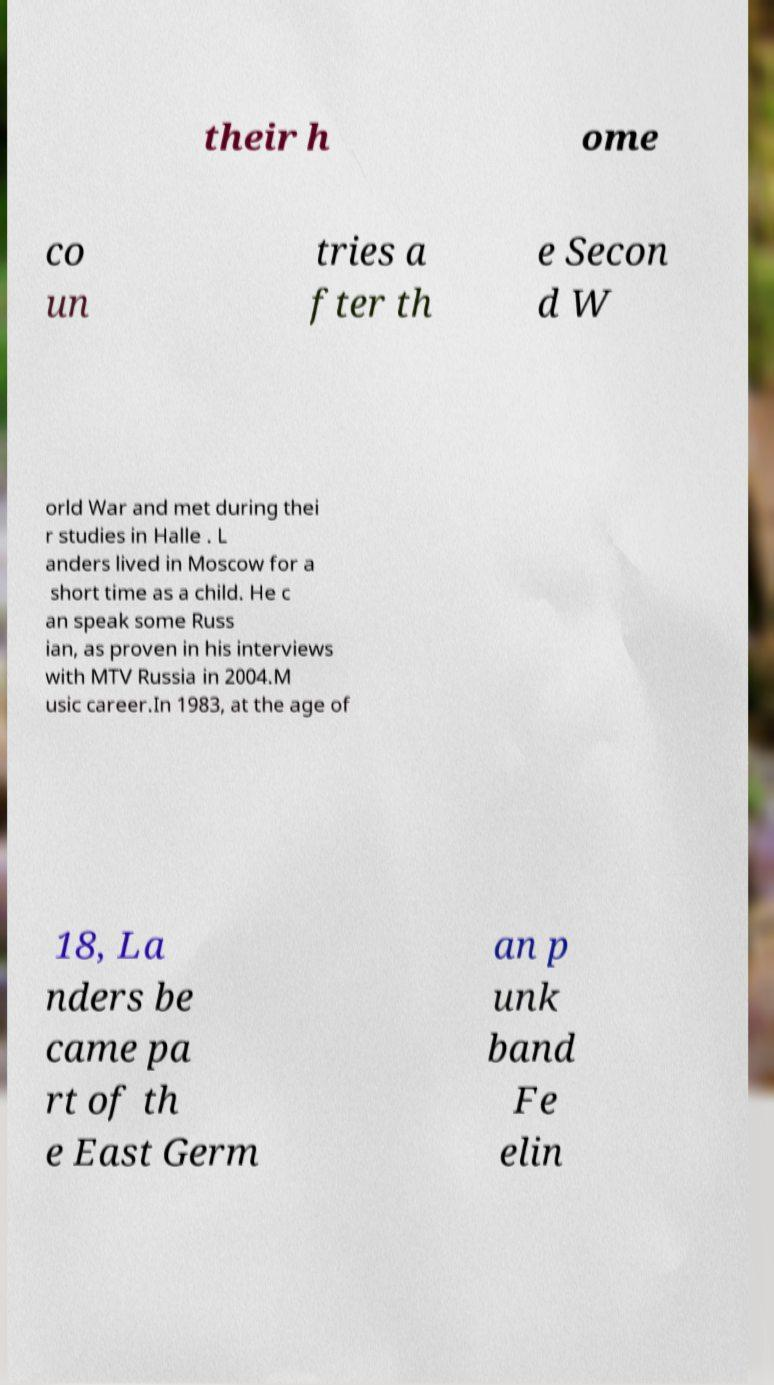Please identify and transcribe the text found in this image. their h ome co un tries a fter th e Secon d W orld War and met during thei r studies in Halle . L anders lived in Moscow for a short time as a child. He c an speak some Russ ian, as proven in his interviews with MTV Russia in 2004.M usic career.In 1983, at the age of 18, La nders be came pa rt of th e East Germ an p unk band Fe elin 